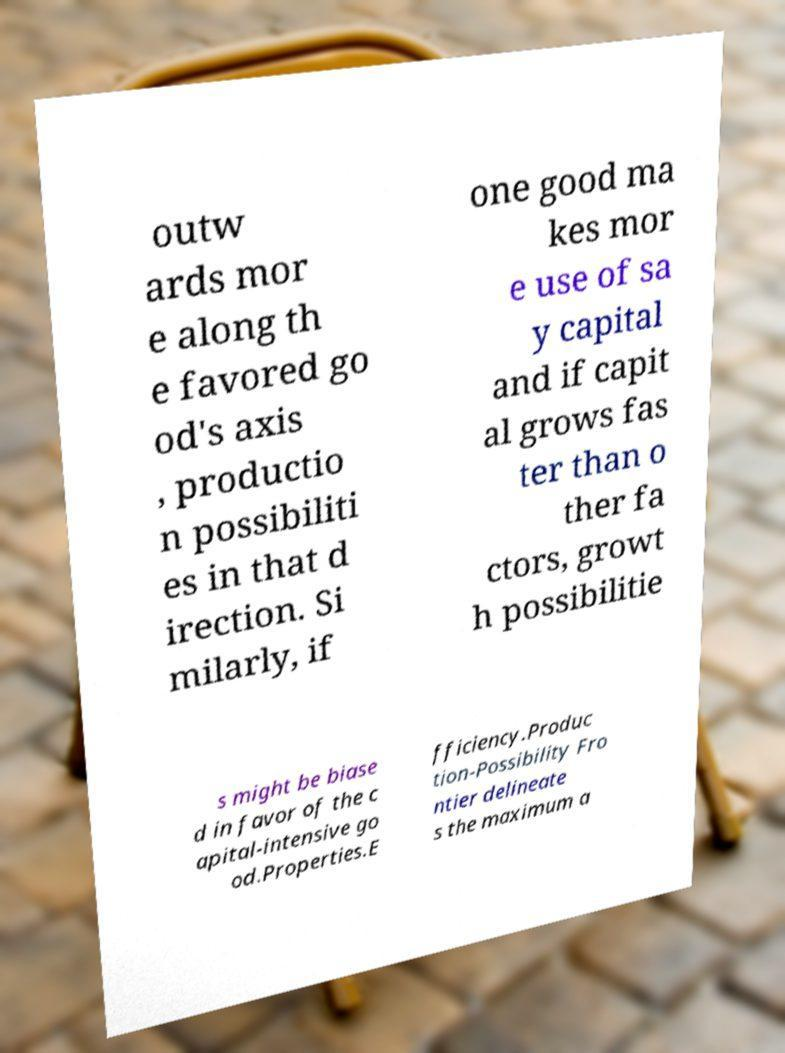Please read and relay the text visible in this image. What does it say? outw ards mor e along th e favored go od's axis , productio n possibiliti es in that d irection. Si milarly, if one good ma kes mor e use of sa y capital and if capit al grows fas ter than o ther fa ctors, growt h possibilitie s might be biase d in favor of the c apital-intensive go od.Properties.E fficiency.Produc tion-Possibility Fro ntier delineate s the maximum a 